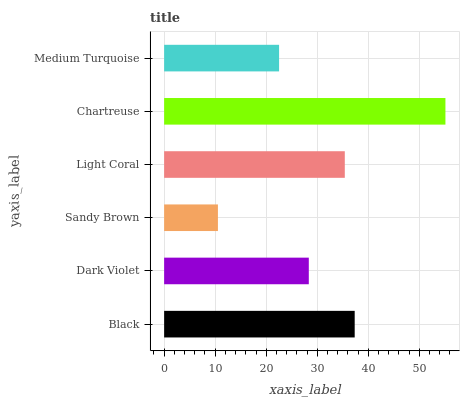Is Sandy Brown the minimum?
Answer yes or no. Yes. Is Chartreuse the maximum?
Answer yes or no. Yes. Is Dark Violet the minimum?
Answer yes or no. No. Is Dark Violet the maximum?
Answer yes or no. No. Is Black greater than Dark Violet?
Answer yes or no. Yes. Is Dark Violet less than Black?
Answer yes or no. Yes. Is Dark Violet greater than Black?
Answer yes or no. No. Is Black less than Dark Violet?
Answer yes or no. No. Is Light Coral the high median?
Answer yes or no. Yes. Is Dark Violet the low median?
Answer yes or no. Yes. Is Medium Turquoise the high median?
Answer yes or no. No. Is Medium Turquoise the low median?
Answer yes or no. No. 